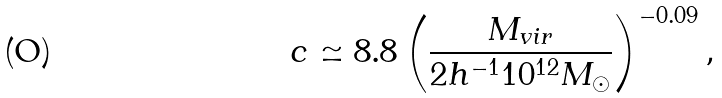Convert formula to latex. <formula><loc_0><loc_0><loc_500><loc_500>c \simeq 8 . 8 \left ( \frac { M _ { v i r } } { 2 h ^ { - 1 } 1 0 ^ { 1 2 } M _ { \odot } } \right ) ^ { - 0 . 0 9 } ,</formula> 